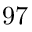<formula> <loc_0><loc_0><loc_500><loc_500>9 7</formula> 